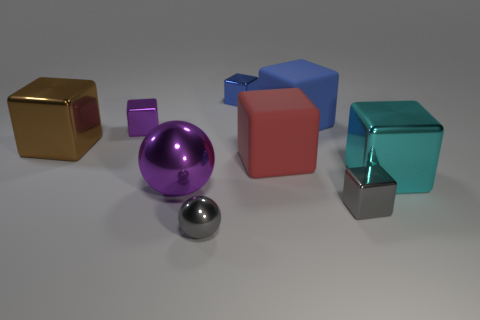Does the tiny shiny sphere have the same color as the large ball?
Your response must be concise. No. What is the size of the purple metal thing in front of the object that is to the right of the gray block?
Your response must be concise. Large. Do the large block that is left of the purple ball and the cube that is behind the large blue matte block have the same material?
Your response must be concise. Yes. Does the block that is right of the gray cube have the same color as the tiny sphere?
Provide a succinct answer. No. There is a small shiny ball; what number of big purple objects are right of it?
Offer a very short reply. 0. Are the big brown thing and the ball that is to the left of the gray shiny ball made of the same material?
Your answer should be very brief. Yes. There is a purple cube that is the same material as the small gray sphere; what is its size?
Keep it short and to the point. Small. Is the number of cyan blocks on the right side of the cyan cube greater than the number of small metallic spheres left of the tiny purple metallic thing?
Ensure brevity in your answer.  No. Are there any gray metal objects of the same shape as the small blue thing?
Your response must be concise. Yes. Does the purple thing that is in front of the cyan metallic thing have the same size as the big brown shiny thing?
Your answer should be very brief. Yes. 